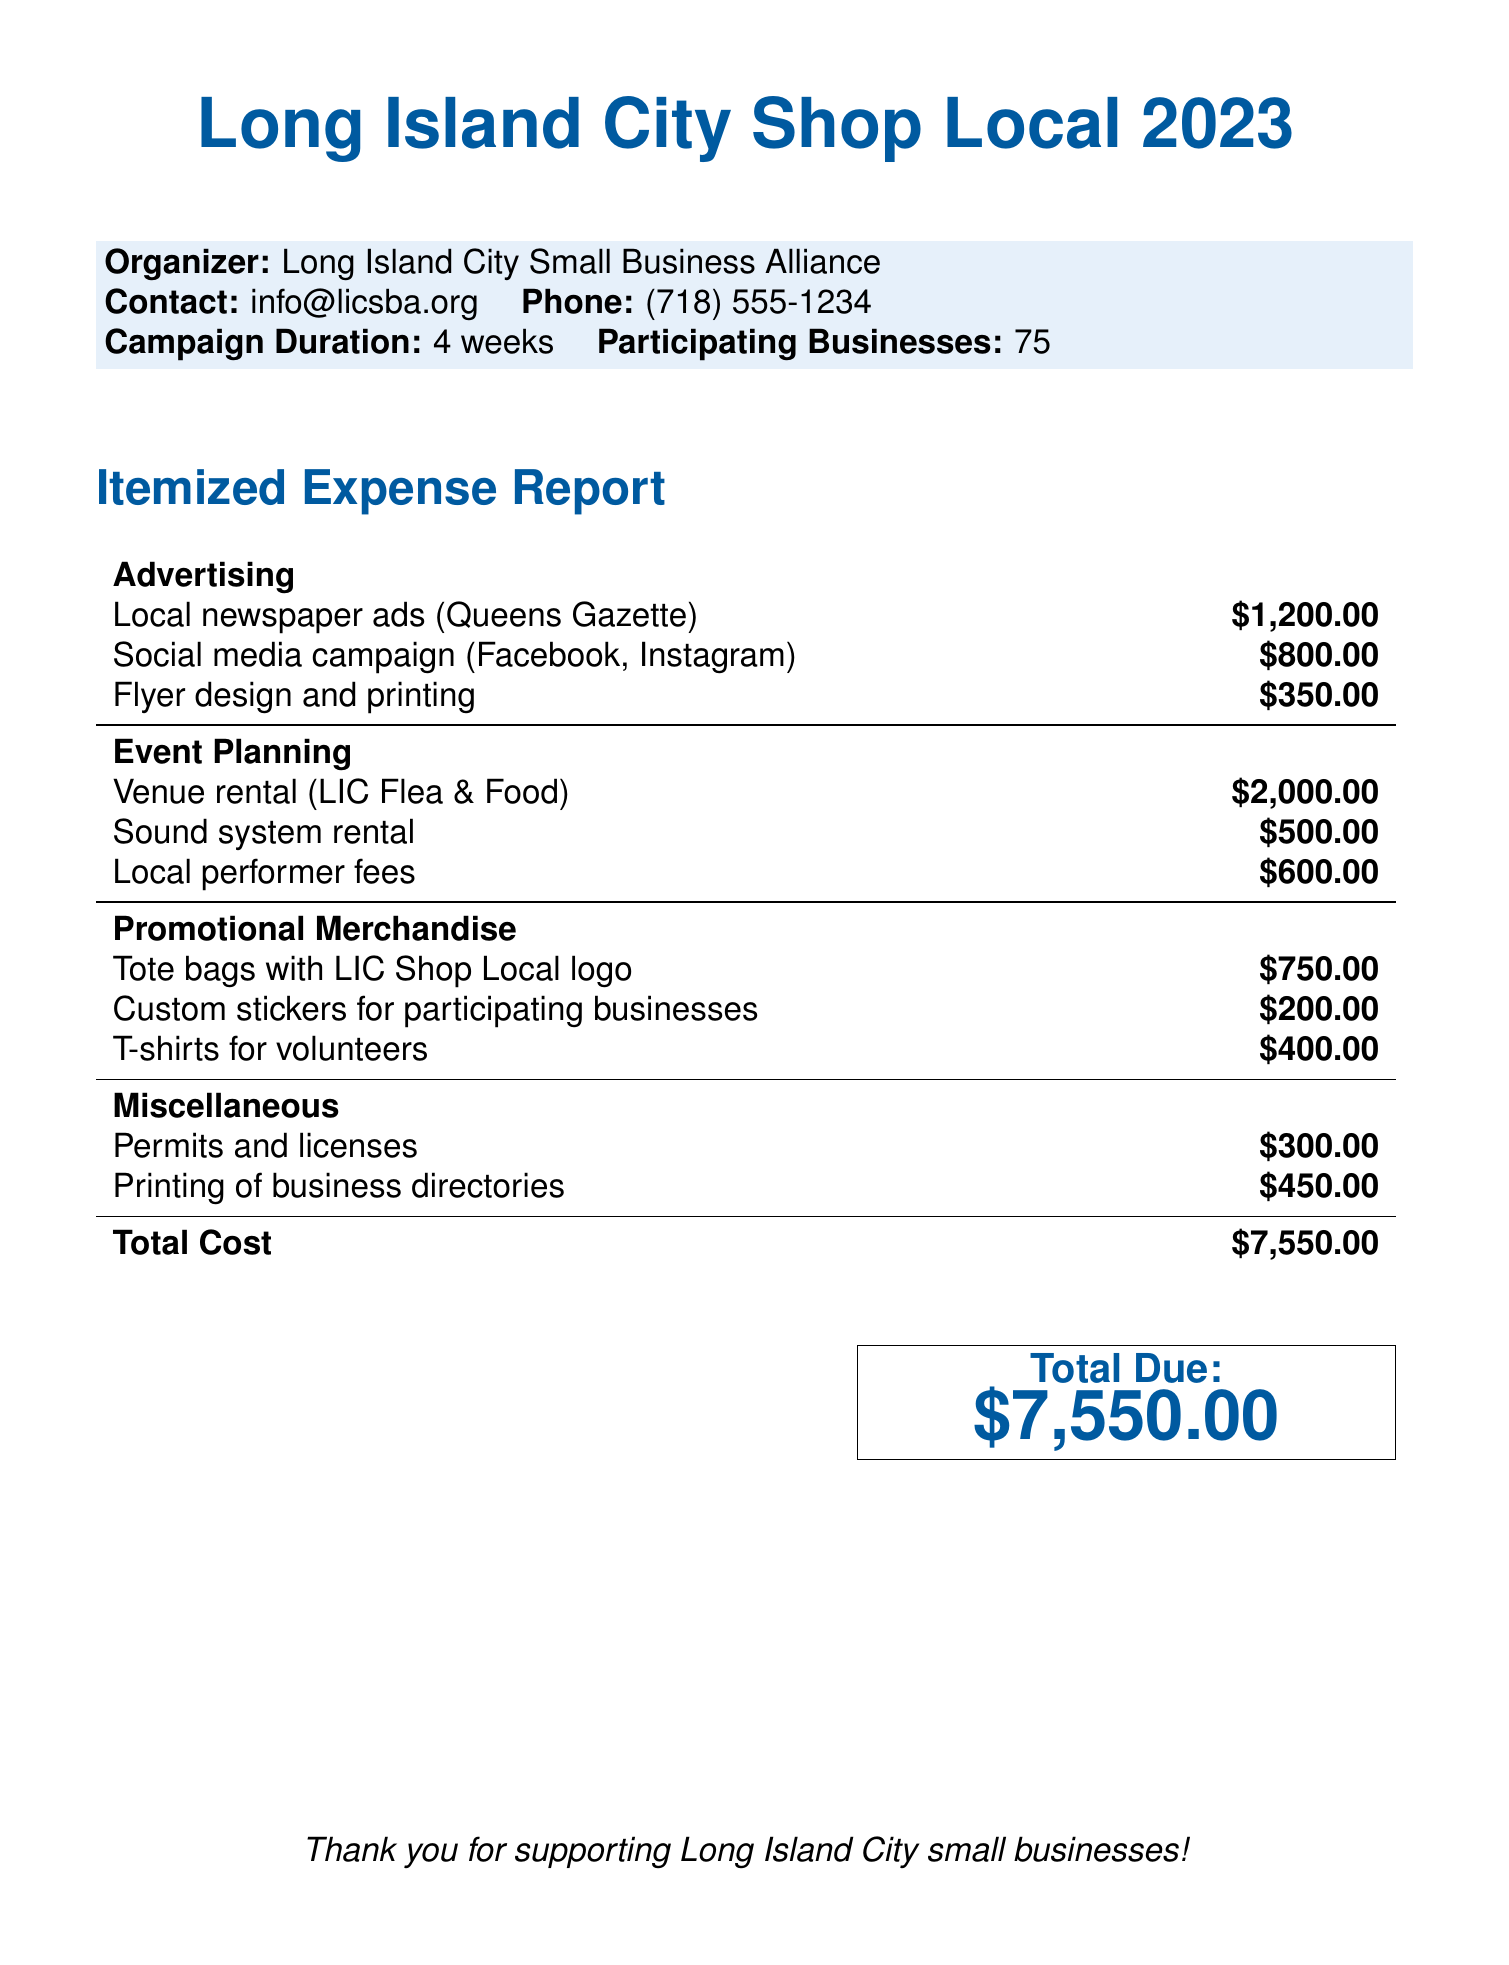What is the total cost of the campaign? The total cost is explicitly stated at the bottom of the expense report.
Answer: $7,550.00 Who is the organizer of the campaign? The document specifies that the Long Island City Small Business Alliance is the organizer.
Answer: Long Island City Small Business Alliance How many participating businesses are involved in the campaign? The document mentions that there are 75 participating businesses.
Answer: 75 What is the cost of local newspaper ads? The expense report lists the cost of local newspaper ads in the advertising section.
Answer: $1,200.00 What are the fees for local performers? The fees for local performers are included in the event planning expenses.
Answer: $600.00 What promotional merchandise includes tote bags? The document lists tote bags as part of the promotional merchandise section.
Answer: Tote bags with LIC Shop Local logo What are the total costs for event planning? The total costs for event planning can be determined by summing the individual event planning expenses.
Answer: $3,100.00 What is the cost for printing business directories? This expense is noted in the miscellaneous section of the report.
Answer: $450.00 What contact information is provided for the organizer? The document includes an email and phone number for contacting the organizer.
Answer: info@licsba.org and (718) 555-1234 